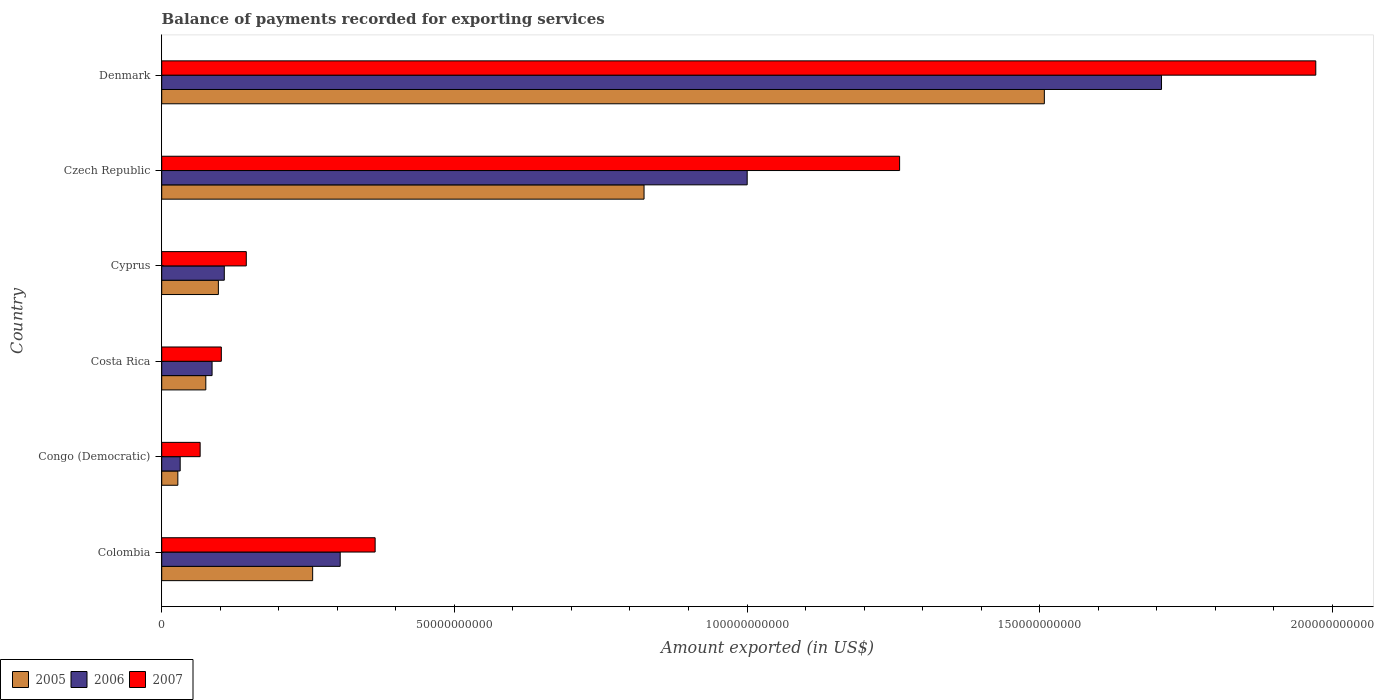How many different coloured bars are there?
Keep it short and to the point. 3. Are the number of bars per tick equal to the number of legend labels?
Provide a short and direct response. Yes. Are the number of bars on each tick of the Y-axis equal?
Provide a short and direct response. Yes. What is the label of the 3rd group of bars from the top?
Offer a very short reply. Cyprus. In how many cases, is the number of bars for a given country not equal to the number of legend labels?
Ensure brevity in your answer.  0. What is the amount exported in 2006 in Colombia?
Offer a terse response. 3.05e+1. Across all countries, what is the maximum amount exported in 2005?
Your response must be concise. 1.51e+11. Across all countries, what is the minimum amount exported in 2005?
Your answer should be compact. 2.76e+09. In which country was the amount exported in 2005 maximum?
Provide a short and direct response. Denmark. In which country was the amount exported in 2007 minimum?
Ensure brevity in your answer.  Congo (Democratic). What is the total amount exported in 2007 in the graph?
Offer a very short reply. 3.91e+11. What is the difference between the amount exported in 2005 in Cyprus and that in Czech Republic?
Give a very brief answer. -7.27e+1. What is the difference between the amount exported in 2007 in Czech Republic and the amount exported in 2005 in Cyprus?
Ensure brevity in your answer.  1.16e+11. What is the average amount exported in 2007 per country?
Ensure brevity in your answer.  6.51e+1. What is the difference between the amount exported in 2006 and amount exported in 2005 in Czech Republic?
Your response must be concise. 1.76e+1. In how many countries, is the amount exported in 2005 greater than 170000000000 US$?
Ensure brevity in your answer.  0. What is the ratio of the amount exported in 2006 in Colombia to that in Czech Republic?
Your answer should be very brief. 0.3. Is the amount exported in 2005 in Cyprus less than that in Denmark?
Ensure brevity in your answer.  Yes. Is the difference between the amount exported in 2006 in Colombia and Cyprus greater than the difference between the amount exported in 2005 in Colombia and Cyprus?
Offer a very short reply. Yes. What is the difference between the highest and the second highest amount exported in 2006?
Your answer should be compact. 7.08e+1. What is the difference between the highest and the lowest amount exported in 2006?
Your answer should be compact. 1.68e+11. In how many countries, is the amount exported in 2005 greater than the average amount exported in 2005 taken over all countries?
Ensure brevity in your answer.  2. Is the sum of the amount exported in 2006 in Colombia and Costa Rica greater than the maximum amount exported in 2005 across all countries?
Your answer should be very brief. No. What does the 1st bar from the top in Cyprus represents?
Offer a very short reply. 2007. What does the 3rd bar from the bottom in Czech Republic represents?
Offer a very short reply. 2007. Is it the case that in every country, the sum of the amount exported in 2007 and amount exported in 2005 is greater than the amount exported in 2006?
Provide a short and direct response. Yes. Are all the bars in the graph horizontal?
Your response must be concise. Yes. How many countries are there in the graph?
Ensure brevity in your answer.  6. Does the graph contain any zero values?
Make the answer very short. No. Does the graph contain grids?
Your answer should be very brief. No. Where does the legend appear in the graph?
Provide a succinct answer. Bottom left. How many legend labels are there?
Ensure brevity in your answer.  3. What is the title of the graph?
Your answer should be compact. Balance of payments recorded for exporting services. Does "2010" appear as one of the legend labels in the graph?
Ensure brevity in your answer.  No. What is the label or title of the X-axis?
Provide a succinct answer. Amount exported (in US$). What is the Amount exported (in US$) of 2005 in Colombia?
Ensure brevity in your answer.  2.58e+1. What is the Amount exported (in US$) in 2006 in Colombia?
Give a very brief answer. 3.05e+1. What is the Amount exported (in US$) in 2007 in Colombia?
Offer a very short reply. 3.65e+1. What is the Amount exported (in US$) in 2005 in Congo (Democratic)?
Give a very brief answer. 2.76e+09. What is the Amount exported (in US$) in 2006 in Congo (Democratic)?
Your response must be concise. 3.16e+09. What is the Amount exported (in US$) in 2007 in Congo (Democratic)?
Your answer should be very brief. 6.57e+09. What is the Amount exported (in US$) of 2005 in Costa Rica?
Keep it short and to the point. 7.54e+09. What is the Amount exported (in US$) in 2006 in Costa Rica?
Make the answer very short. 8.60e+09. What is the Amount exported (in US$) in 2007 in Costa Rica?
Provide a succinct answer. 1.02e+1. What is the Amount exported (in US$) of 2005 in Cyprus?
Provide a short and direct response. 9.68e+09. What is the Amount exported (in US$) of 2006 in Cyprus?
Your answer should be compact. 1.07e+1. What is the Amount exported (in US$) of 2007 in Cyprus?
Your answer should be compact. 1.44e+1. What is the Amount exported (in US$) of 2005 in Czech Republic?
Offer a very short reply. 8.24e+1. What is the Amount exported (in US$) of 2006 in Czech Republic?
Your answer should be compact. 1.00e+11. What is the Amount exported (in US$) of 2007 in Czech Republic?
Keep it short and to the point. 1.26e+11. What is the Amount exported (in US$) of 2005 in Denmark?
Your answer should be very brief. 1.51e+11. What is the Amount exported (in US$) of 2006 in Denmark?
Offer a very short reply. 1.71e+11. What is the Amount exported (in US$) in 2007 in Denmark?
Your answer should be very brief. 1.97e+11. Across all countries, what is the maximum Amount exported (in US$) in 2005?
Provide a short and direct response. 1.51e+11. Across all countries, what is the maximum Amount exported (in US$) of 2006?
Keep it short and to the point. 1.71e+11. Across all countries, what is the maximum Amount exported (in US$) of 2007?
Provide a short and direct response. 1.97e+11. Across all countries, what is the minimum Amount exported (in US$) in 2005?
Provide a short and direct response. 2.76e+09. Across all countries, what is the minimum Amount exported (in US$) in 2006?
Your response must be concise. 3.16e+09. Across all countries, what is the minimum Amount exported (in US$) in 2007?
Provide a short and direct response. 6.57e+09. What is the total Amount exported (in US$) in 2005 in the graph?
Provide a succinct answer. 2.79e+11. What is the total Amount exported (in US$) of 2006 in the graph?
Offer a terse response. 3.24e+11. What is the total Amount exported (in US$) of 2007 in the graph?
Offer a very short reply. 3.91e+11. What is the difference between the Amount exported (in US$) of 2005 in Colombia and that in Congo (Democratic)?
Keep it short and to the point. 2.30e+1. What is the difference between the Amount exported (in US$) of 2006 in Colombia and that in Congo (Democratic)?
Provide a short and direct response. 2.73e+1. What is the difference between the Amount exported (in US$) of 2007 in Colombia and that in Congo (Democratic)?
Your answer should be compact. 2.99e+1. What is the difference between the Amount exported (in US$) of 2005 in Colombia and that in Costa Rica?
Keep it short and to the point. 1.83e+1. What is the difference between the Amount exported (in US$) of 2006 in Colombia and that in Costa Rica?
Keep it short and to the point. 2.19e+1. What is the difference between the Amount exported (in US$) in 2007 in Colombia and that in Costa Rica?
Ensure brevity in your answer.  2.63e+1. What is the difference between the Amount exported (in US$) in 2005 in Colombia and that in Cyprus?
Provide a succinct answer. 1.61e+1. What is the difference between the Amount exported (in US$) in 2006 in Colombia and that in Cyprus?
Offer a terse response. 1.98e+1. What is the difference between the Amount exported (in US$) in 2007 in Colombia and that in Cyprus?
Keep it short and to the point. 2.20e+1. What is the difference between the Amount exported (in US$) of 2005 in Colombia and that in Czech Republic?
Offer a terse response. -5.66e+1. What is the difference between the Amount exported (in US$) in 2006 in Colombia and that in Czech Republic?
Offer a terse response. -6.95e+1. What is the difference between the Amount exported (in US$) in 2007 in Colombia and that in Czech Republic?
Your answer should be very brief. -8.96e+1. What is the difference between the Amount exported (in US$) in 2005 in Colombia and that in Denmark?
Offer a terse response. -1.25e+11. What is the difference between the Amount exported (in US$) of 2006 in Colombia and that in Denmark?
Provide a succinct answer. -1.40e+11. What is the difference between the Amount exported (in US$) in 2007 in Colombia and that in Denmark?
Give a very brief answer. -1.61e+11. What is the difference between the Amount exported (in US$) of 2005 in Congo (Democratic) and that in Costa Rica?
Make the answer very short. -4.78e+09. What is the difference between the Amount exported (in US$) in 2006 in Congo (Democratic) and that in Costa Rica?
Make the answer very short. -5.45e+09. What is the difference between the Amount exported (in US$) in 2007 in Congo (Democratic) and that in Costa Rica?
Your answer should be very brief. -3.62e+09. What is the difference between the Amount exported (in US$) in 2005 in Congo (Democratic) and that in Cyprus?
Give a very brief answer. -6.93e+09. What is the difference between the Amount exported (in US$) of 2006 in Congo (Democratic) and that in Cyprus?
Your answer should be compact. -7.54e+09. What is the difference between the Amount exported (in US$) in 2007 in Congo (Democratic) and that in Cyprus?
Keep it short and to the point. -7.88e+09. What is the difference between the Amount exported (in US$) in 2005 in Congo (Democratic) and that in Czech Republic?
Provide a succinct answer. -7.96e+1. What is the difference between the Amount exported (in US$) in 2006 in Congo (Democratic) and that in Czech Republic?
Keep it short and to the point. -9.69e+1. What is the difference between the Amount exported (in US$) of 2007 in Congo (Democratic) and that in Czech Republic?
Ensure brevity in your answer.  -1.19e+11. What is the difference between the Amount exported (in US$) of 2005 in Congo (Democratic) and that in Denmark?
Offer a very short reply. -1.48e+11. What is the difference between the Amount exported (in US$) of 2006 in Congo (Democratic) and that in Denmark?
Your answer should be very brief. -1.68e+11. What is the difference between the Amount exported (in US$) of 2007 in Congo (Democratic) and that in Denmark?
Your response must be concise. -1.91e+11. What is the difference between the Amount exported (in US$) in 2005 in Costa Rica and that in Cyprus?
Provide a short and direct response. -2.15e+09. What is the difference between the Amount exported (in US$) of 2006 in Costa Rica and that in Cyprus?
Keep it short and to the point. -2.09e+09. What is the difference between the Amount exported (in US$) in 2007 in Costa Rica and that in Cyprus?
Your response must be concise. -4.27e+09. What is the difference between the Amount exported (in US$) of 2005 in Costa Rica and that in Czech Republic?
Provide a succinct answer. -7.49e+1. What is the difference between the Amount exported (in US$) of 2006 in Costa Rica and that in Czech Republic?
Ensure brevity in your answer.  -9.14e+1. What is the difference between the Amount exported (in US$) in 2007 in Costa Rica and that in Czech Republic?
Offer a terse response. -1.16e+11. What is the difference between the Amount exported (in US$) of 2005 in Costa Rica and that in Denmark?
Offer a very short reply. -1.43e+11. What is the difference between the Amount exported (in US$) of 2006 in Costa Rica and that in Denmark?
Make the answer very short. -1.62e+11. What is the difference between the Amount exported (in US$) in 2007 in Costa Rica and that in Denmark?
Give a very brief answer. -1.87e+11. What is the difference between the Amount exported (in US$) of 2005 in Cyprus and that in Czech Republic?
Provide a succinct answer. -7.27e+1. What is the difference between the Amount exported (in US$) of 2006 in Cyprus and that in Czech Republic?
Provide a succinct answer. -8.93e+1. What is the difference between the Amount exported (in US$) of 2007 in Cyprus and that in Czech Republic?
Give a very brief answer. -1.12e+11. What is the difference between the Amount exported (in US$) of 2005 in Cyprus and that in Denmark?
Your response must be concise. -1.41e+11. What is the difference between the Amount exported (in US$) in 2006 in Cyprus and that in Denmark?
Offer a terse response. -1.60e+11. What is the difference between the Amount exported (in US$) of 2007 in Cyprus and that in Denmark?
Provide a short and direct response. -1.83e+11. What is the difference between the Amount exported (in US$) in 2005 in Czech Republic and that in Denmark?
Make the answer very short. -6.84e+1. What is the difference between the Amount exported (in US$) of 2006 in Czech Republic and that in Denmark?
Ensure brevity in your answer.  -7.08e+1. What is the difference between the Amount exported (in US$) of 2007 in Czech Republic and that in Denmark?
Make the answer very short. -7.11e+1. What is the difference between the Amount exported (in US$) of 2005 in Colombia and the Amount exported (in US$) of 2006 in Congo (Democratic)?
Keep it short and to the point. 2.26e+1. What is the difference between the Amount exported (in US$) of 2005 in Colombia and the Amount exported (in US$) of 2007 in Congo (Democratic)?
Make the answer very short. 1.92e+1. What is the difference between the Amount exported (in US$) of 2006 in Colombia and the Amount exported (in US$) of 2007 in Congo (Democratic)?
Keep it short and to the point. 2.39e+1. What is the difference between the Amount exported (in US$) in 2005 in Colombia and the Amount exported (in US$) in 2006 in Costa Rica?
Provide a short and direct response. 1.72e+1. What is the difference between the Amount exported (in US$) of 2005 in Colombia and the Amount exported (in US$) of 2007 in Costa Rica?
Keep it short and to the point. 1.56e+1. What is the difference between the Amount exported (in US$) in 2006 in Colombia and the Amount exported (in US$) in 2007 in Costa Rica?
Offer a very short reply. 2.03e+1. What is the difference between the Amount exported (in US$) of 2005 in Colombia and the Amount exported (in US$) of 2006 in Cyprus?
Your answer should be compact. 1.51e+1. What is the difference between the Amount exported (in US$) of 2005 in Colombia and the Amount exported (in US$) of 2007 in Cyprus?
Offer a terse response. 1.13e+1. What is the difference between the Amount exported (in US$) of 2006 in Colombia and the Amount exported (in US$) of 2007 in Cyprus?
Your response must be concise. 1.60e+1. What is the difference between the Amount exported (in US$) of 2005 in Colombia and the Amount exported (in US$) of 2006 in Czech Republic?
Keep it short and to the point. -7.42e+1. What is the difference between the Amount exported (in US$) of 2005 in Colombia and the Amount exported (in US$) of 2007 in Czech Republic?
Keep it short and to the point. -1.00e+11. What is the difference between the Amount exported (in US$) in 2006 in Colombia and the Amount exported (in US$) in 2007 in Czech Republic?
Ensure brevity in your answer.  -9.56e+1. What is the difference between the Amount exported (in US$) of 2005 in Colombia and the Amount exported (in US$) of 2006 in Denmark?
Provide a succinct answer. -1.45e+11. What is the difference between the Amount exported (in US$) in 2005 in Colombia and the Amount exported (in US$) in 2007 in Denmark?
Offer a terse response. -1.71e+11. What is the difference between the Amount exported (in US$) in 2006 in Colombia and the Amount exported (in US$) in 2007 in Denmark?
Make the answer very short. -1.67e+11. What is the difference between the Amount exported (in US$) of 2005 in Congo (Democratic) and the Amount exported (in US$) of 2006 in Costa Rica?
Offer a very short reply. -5.85e+09. What is the difference between the Amount exported (in US$) of 2005 in Congo (Democratic) and the Amount exported (in US$) of 2007 in Costa Rica?
Your response must be concise. -7.43e+09. What is the difference between the Amount exported (in US$) of 2006 in Congo (Democratic) and the Amount exported (in US$) of 2007 in Costa Rica?
Ensure brevity in your answer.  -7.03e+09. What is the difference between the Amount exported (in US$) of 2005 in Congo (Democratic) and the Amount exported (in US$) of 2006 in Cyprus?
Offer a terse response. -7.94e+09. What is the difference between the Amount exported (in US$) in 2005 in Congo (Democratic) and the Amount exported (in US$) in 2007 in Cyprus?
Give a very brief answer. -1.17e+1. What is the difference between the Amount exported (in US$) in 2006 in Congo (Democratic) and the Amount exported (in US$) in 2007 in Cyprus?
Keep it short and to the point. -1.13e+1. What is the difference between the Amount exported (in US$) of 2005 in Congo (Democratic) and the Amount exported (in US$) of 2006 in Czech Republic?
Provide a succinct answer. -9.73e+1. What is the difference between the Amount exported (in US$) in 2005 in Congo (Democratic) and the Amount exported (in US$) in 2007 in Czech Republic?
Give a very brief answer. -1.23e+11. What is the difference between the Amount exported (in US$) in 2006 in Congo (Democratic) and the Amount exported (in US$) in 2007 in Czech Republic?
Your answer should be very brief. -1.23e+11. What is the difference between the Amount exported (in US$) of 2005 in Congo (Democratic) and the Amount exported (in US$) of 2006 in Denmark?
Keep it short and to the point. -1.68e+11. What is the difference between the Amount exported (in US$) in 2005 in Congo (Democratic) and the Amount exported (in US$) in 2007 in Denmark?
Your response must be concise. -1.94e+11. What is the difference between the Amount exported (in US$) in 2006 in Congo (Democratic) and the Amount exported (in US$) in 2007 in Denmark?
Your response must be concise. -1.94e+11. What is the difference between the Amount exported (in US$) in 2005 in Costa Rica and the Amount exported (in US$) in 2006 in Cyprus?
Keep it short and to the point. -3.16e+09. What is the difference between the Amount exported (in US$) in 2005 in Costa Rica and the Amount exported (in US$) in 2007 in Cyprus?
Ensure brevity in your answer.  -6.91e+09. What is the difference between the Amount exported (in US$) of 2006 in Costa Rica and the Amount exported (in US$) of 2007 in Cyprus?
Make the answer very short. -5.84e+09. What is the difference between the Amount exported (in US$) in 2005 in Costa Rica and the Amount exported (in US$) in 2006 in Czech Republic?
Provide a succinct answer. -9.25e+1. What is the difference between the Amount exported (in US$) of 2005 in Costa Rica and the Amount exported (in US$) of 2007 in Czech Republic?
Provide a succinct answer. -1.19e+11. What is the difference between the Amount exported (in US$) in 2006 in Costa Rica and the Amount exported (in US$) in 2007 in Czech Republic?
Offer a very short reply. -1.17e+11. What is the difference between the Amount exported (in US$) of 2005 in Costa Rica and the Amount exported (in US$) of 2006 in Denmark?
Your answer should be very brief. -1.63e+11. What is the difference between the Amount exported (in US$) of 2005 in Costa Rica and the Amount exported (in US$) of 2007 in Denmark?
Your response must be concise. -1.90e+11. What is the difference between the Amount exported (in US$) in 2006 in Costa Rica and the Amount exported (in US$) in 2007 in Denmark?
Ensure brevity in your answer.  -1.89e+11. What is the difference between the Amount exported (in US$) of 2005 in Cyprus and the Amount exported (in US$) of 2006 in Czech Republic?
Give a very brief answer. -9.03e+1. What is the difference between the Amount exported (in US$) of 2005 in Cyprus and the Amount exported (in US$) of 2007 in Czech Republic?
Make the answer very short. -1.16e+11. What is the difference between the Amount exported (in US$) of 2006 in Cyprus and the Amount exported (in US$) of 2007 in Czech Republic?
Your answer should be compact. -1.15e+11. What is the difference between the Amount exported (in US$) of 2005 in Cyprus and the Amount exported (in US$) of 2006 in Denmark?
Keep it short and to the point. -1.61e+11. What is the difference between the Amount exported (in US$) in 2005 in Cyprus and the Amount exported (in US$) in 2007 in Denmark?
Offer a terse response. -1.87e+11. What is the difference between the Amount exported (in US$) in 2006 in Cyprus and the Amount exported (in US$) in 2007 in Denmark?
Give a very brief answer. -1.86e+11. What is the difference between the Amount exported (in US$) of 2005 in Czech Republic and the Amount exported (in US$) of 2006 in Denmark?
Ensure brevity in your answer.  -8.84e+1. What is the difference between the Amount exported (in US$) in 2005 in Czech Republic and the Amount exported (in US$) in 2007 in Denmark?
Your response must be concise. -1.15e+11. What is the difference between the Amount exported (in US$) of 2006 in Czech Republic and the Amount exported (in US$) of 2007 in Denmark?
Offer a very short reply. -9.71e+1. What is the average Amount exported (in US$) of 2005 per country?
Your answer should be very brief. 4.65e+1. What is the average Amount exported (in US$) of 2006 per country?
Your answer should be compact. 5.40e+1. What is the average Amount exported (in US$) of 2007 per country?
Your response must be concise. 6.51e+1. What is the difference between the Amount exported (in US$) of 2005 and Amount exported (in US$) of 2006 in Colombia?
Your answer should be very brief. -4.70e+09. What is the difference between the Amount exported (in US$) in 2005 and Amount exported (in US$) in 2007 in Colombia?
Make the answer very short. -1.07e+1. What is the difference between the Amount exported (in US$) of 2006 and Amount exported (in US$) of 2007 in Colombia?
Make the answer very short. -5.97e+09. What is the difference between the Amount exported (in US$) in 2005 and Amount exported (in US$) in 2006 in Congo (Democratic)?
Offer a very short reply. -4.00e+08. What is the difference between the Amount exported (in US$) in 2005 and Amount exported (in US$) in 2007 in Congo (Democratic)?
Provide a short and direct response. -3.81e+09. What is the difference between the Amount exported (in US$) in 2006 and Amount exported (in US$) in 2007 in Congo (Democratic)?
Offer a very short reply. -3.41e+09. What is the difference between the Amount exported (in US$) of 2005 and Amount exported (in US$) of 2006 in Costa Rica?
Offer a very short reply. -1.07e+09. What is the difference between the Amount exported (in US$) of 2005 and Amount exported (in US$) of 2007 in Costa Rica?
Ensure brevity in your answer.  -2.65e+09. What is the difference between the Amount exported (in US$) of 2006 and Amount exported (in US$) of 2007 in Costa Rica?
Provide a short and direct response. -1.58e+09. What is the difference between the Amount exported (in US$) of 2005 and Amount exported (in US$) of 2006 in Cyprus?
Provide a short and direct response. -1.01e+09. What is the difference between the Amount exported (in US$) of 2005 and Amount exported (in US$) of 2007 in Cyprus?
Offer a very short reply. -4.77e+09. What is the difference between the Amount exported (in US$) in 2006 and Amount exported (in US$) in 2007 in Cyprus?
Your response must be concise. -3.76e+09. What is the difference between the Amount exported (in US$) of 2005 and Amount exported (in US$) of 2006 in Czech Republic?
Keep it short and to the point. -1.76e+1. What is the difference between the Amount exported (in US$) of 2005 and Amount exported (in US$) of 2007 in Czech Republic?
Your answer should be compact. -4.37e+1. What is the difference between the Amount exported (in US$) in 2006 and Amount exported (in US$) in 2007 in Czech Republic?
Make the answer very short. -2.60e+1. What is the difference between the Amount exported (in US$) in 2005 and Amount exported (in US$) in 2006 in Denmark?
Offer a very short reply. -2.00e+1. What is the difference between the Amount exported (in US$) of 2005 and Amount exported (in US$) of 2007 in Denmark?
Your response must be concise. -4.64e+1. What is the difference between the Amount exported (in US$) in 2006 and Amount exported (in US$) in 2007 in Denmark?
Offer a terse response. -2.64e+1. What is the ratio of the Amount exported (in US$) of 2005 in Colombia to that in Congo (Democratic)?
Ensure brevity in your answer.  9.36. What is the ratio of the Amount exported (in US$) of 2006 in Colombia to that in Congo (Democratic)?
Your response must be concise. 9.66. What is the ratio of the Amount exported (in US$) of 2007 in Colombia to that in Congo (Democratic)?
Offer a very short reply. 5.55. What is the ratio of the Amount exported (in US$) of 2005 in Colombia to that in Costa Rica?
Make the answer very short. 3.42. What is the ratio of the Amount exported (in US$) of 2006 in Colombia to that in Costa Rica?
Ensure brevity in your answer.  3.54. What is the ratio of the Amount exported (in US$) of 2007 in Colombia to that in Costa Rica?
Provide a succinct answer. 3.58. What is the ratio of the Amount exported (in US$) of 2005 in Colombia to that in Cyprus?
Provide a short and direct response. 2.66. What is the ratio of the Amount exported (in US$) of 2006 in Colombia to that in Cyprus?
Provide a succinct answer. 2.85. What is the ratio of the Amount exported (in US$) in 2007 in Colombia to that in Cyprus?
Your answer should be compact. 2.52. What is the ratio of the Amount exported (in US$) in 2005 in Colombia to that in Czech Republic?
Make the answer very short. 0.31. What is the ratio of the Amount exported (in US$) in 2006 in Colombia to that in Czech Republic?
Your answer should be compact. 0.3. What is the ratio of the Amount exported (in US$) of 2007 in Colombia to that in Czech Republic?
Keep it short and to the point. 0.29. What is the ratio of the Amount exported (in US$) of 2005 in Colombia to that in Denmark?
Make the answer very short. 0.17. What is the ratio of the Amount exported (in US$) of 2006 in Colombia to that in Denmark?
Provide a succinct answer. 0.18. What is the ratio of the Amount exported (in US$) of 2007 in Colombia to that in Denmark?
Your answer should be very brief. 0.18. What is the ratio of the Amount exported (in US$) of 2005 in Congo (Democratic) to that in Costa Rica?
Keep it short and to the point. 0.37. What is the ratio of the Amount exported (in US$) in 2006 in Congo (Democratic) to that in Costa Rica?
Provide a succinct answer. 0.37. What is the ratio of the Amount exported (in US$) of 2007 in Congo (Democratic) to that in Costa Rica?
Provide a short and direct response. 0.64. What is the ratio of the Amount exported (in US$) in 2005 in Congo (Democratic) to that in Cyprus?
Your answer should be compact. 0.28. What is the ratio of the Amount exported (in US$) of 2006 in Congo (Democratic) to that in Cyprus?
Offer a terse response. 0.3. What is the ratio of the Amount exported (in US$) of 2007 in Congo (Democratic) to that in Cyprus?
Make the answer very short. 0.45. What is the ratio of the Amount exported (in US$) of 2005 in Congo (Democratic) to that in Czech Republic?
Provide a short and direct response. 0.03. What is the ratio of the Amount exported (in US$) in 2006 in Congo (Democratic) to that in Czech Republic?
Your answer should be very brief. 0.03. What is the ratio of the Amount exported (in US$) in 2007 in Congo (Democratic) to that in Czech Republic?
Your response must be concise. 0.05. What is the ratio of the Amount exported (in US$) of 2005 in Congo (Democratic) to that in Denmark?
Keep it short and to the point. 0.02. What is the ratio of the Amount exported (in US$) of 2006 in Congo (Democratic) to that in Denmark?
Provide a short and direct response. 0.02. What is the ratio of the Amount exported (in US$) of 2007 in Congo (Democratic) to that in Denmark?
Give a very brief answer. 0.03. What is the ratio of the Amount exported (in US$) in 2005 in Costa Rica to that in Cyprus?
Give a very brief answer. 0.78. What is the ratio of the Amount exported (in US$) of 2006 in Costa Rica to that in Cyprus?
Make the answer very short. 0.8. What is the ratio of the Amount exported (in US$) in 2007 in Costa Rica to that in Cyprus?
Give a very brief answer. 0.7. What is the ratio of the Amount exported (in US$) in 2005 in Costa Rica to that in Czech Republic?
Provide a succinct answer. 0.09. What is the ratio of the Amount exported (in US$) of 2006 in Costa Rica to that in Czech Republic?
Provide a short and direct response. 0.09. What is the ratio of the Amount exported (in US$) in 2007 in Costa Rica to that in Czech Republic?
Give a very brief answer. 0.08. What is the ratio of the Amount exported (in US$) of 2005 in Costa Rica to that in Denmark?
Ensure brevity in your answer.  0.05. What is the ratio of the Amount exported (in US$) of 2006 in Costa Rica to that in Denmark?
Offer a terse response. 0.05. What is the ratio of the Amount exported (in US$) in 2007 in Costa Rica to that in Denmark?
Keep it short and to the point. 0.05. What is the ratio of the Amount exported (in US$) of 2005 in Cyprus to that in Czech Republic?
Keep it short and to the point. 0.12. What is the ratio of the Amount exported (in US$) of 2006 in Cyprus to that in Czech Republic?
Ensure brevity in your answer.  0.11. What is the ratio of the Amount exported (in US$) of 2007 in Cyprus to that in Czech Republic?
Give a very brief answer. 0.11. What is the ratio of the Amount exported (in US$) in 2005 in Cyprus to that in Denmark?
Keep it short and to the point. 0.06. What is the ratio of the Amount exported (in US$) in 2006 in Cyprus to that in Denmark?
Ensure brevity in your answer.  0.06. What is the ratio of the Amount exported (in US$) in 2007 in Cyprus to that in Denmark?
Your answer should be very brief. 0.07. What is the ratio of the Amount exported (in US$) in 2005 in Czech Republic to that in Denmark?
Your answer should be very brief. 0.55. What is the ratio of the Amount exported (in US$) of 2006 in Czech Republic to that in Denmark?
Offer a terse response. 0.59. What is the ratio of the Amount exported (in US$) in 2007 in Czech Republic to that in Denmark?
Offer a terse response. 0.64. What is the difference between the highest and the second highest Amount exported (in US$) in 2005?
Provide a short and direct response. 6.84e+1. What is the difference between the highest and the second highest Amount exported (in US$) in 2006?
Ensure brevity in your answer.  7.08e+1. What is the difference between the highest and the second highest Amount exported (in US$) in 2007?
Provide a succinct answer. 7.11e+1. What is the difference between the highest and the lowest Amount exported (in US$) of 2005?
Offer a very short reply. 1.48e+11. What is the difference between the highest and the lowest Amount exported (in US$) in 2006?
Your answer should be compact. 1.68e+11. What is the difference between the highest and the lowest Amount exported (in US$) of 2007?
Your answer should be very brief. 1.91e+11. 